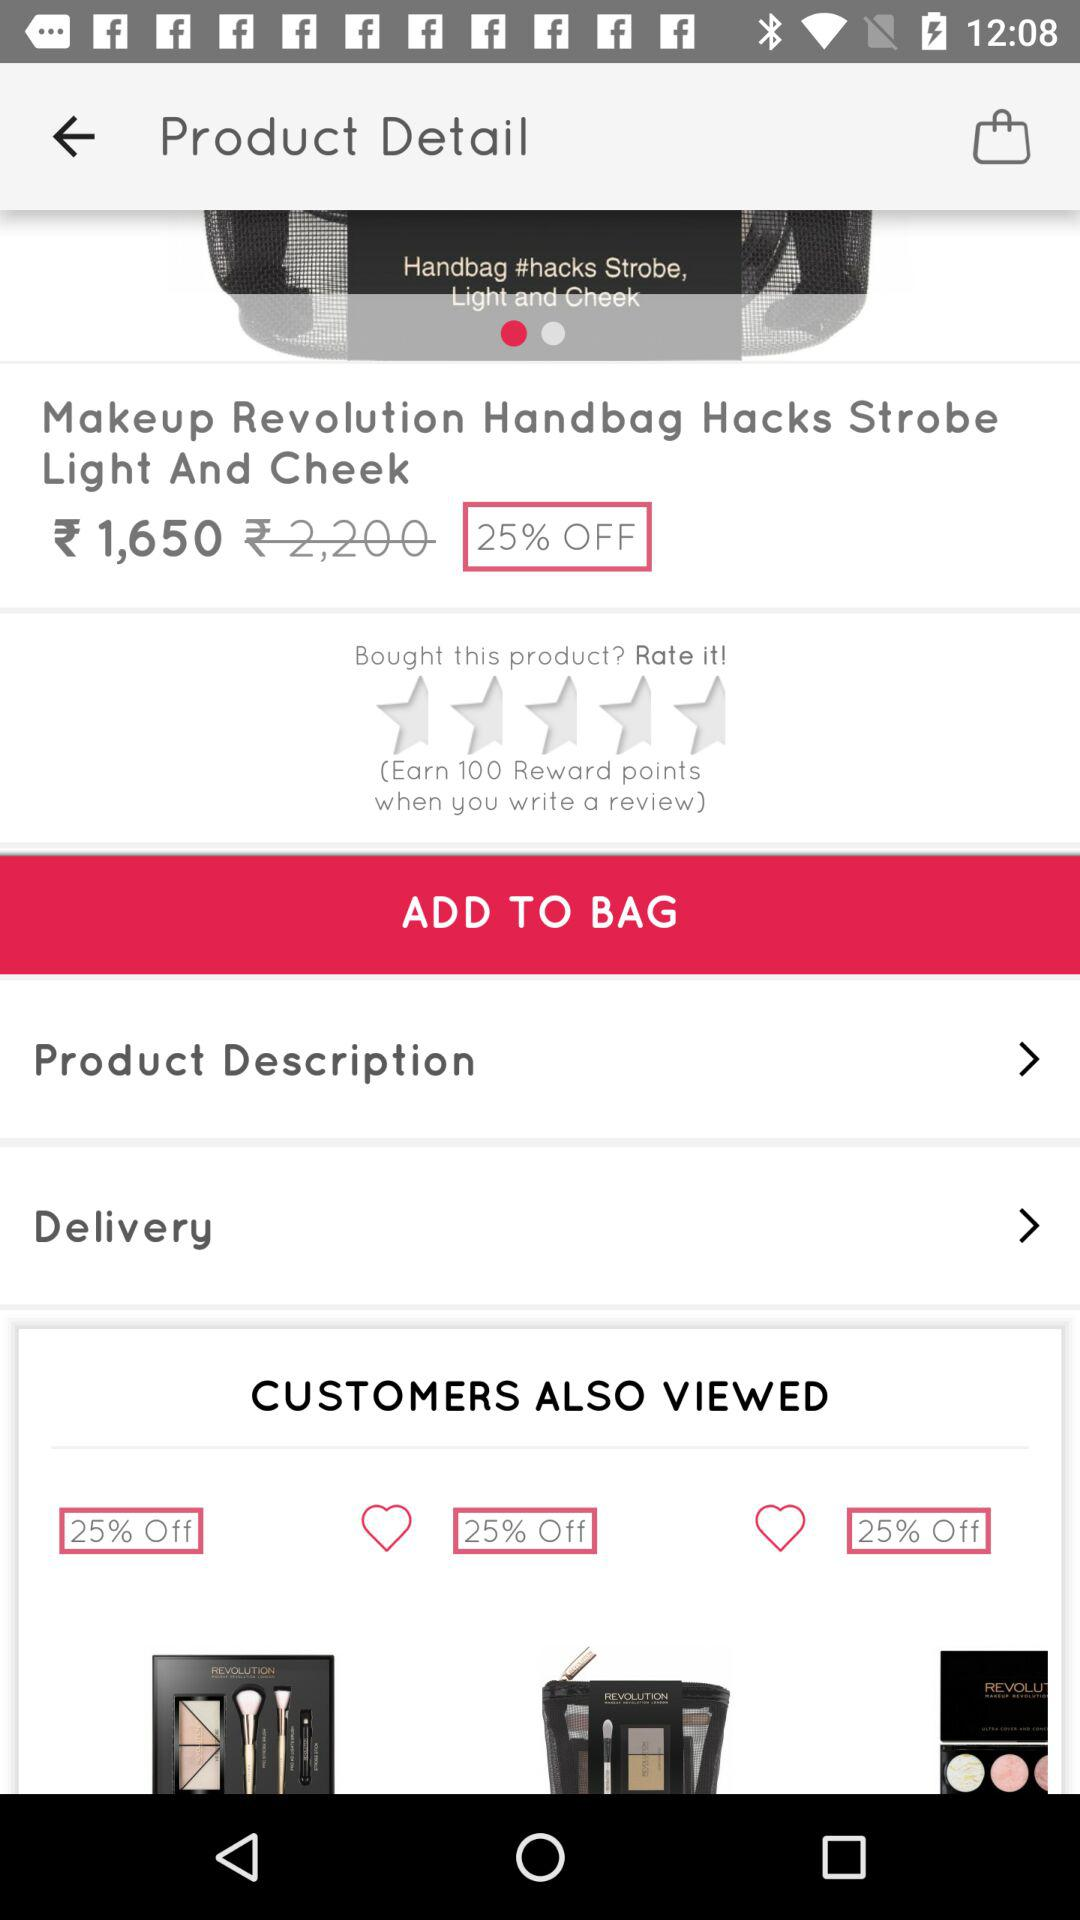How much is the discount on the product?
Answer the question using a single word or phrase. 25% 